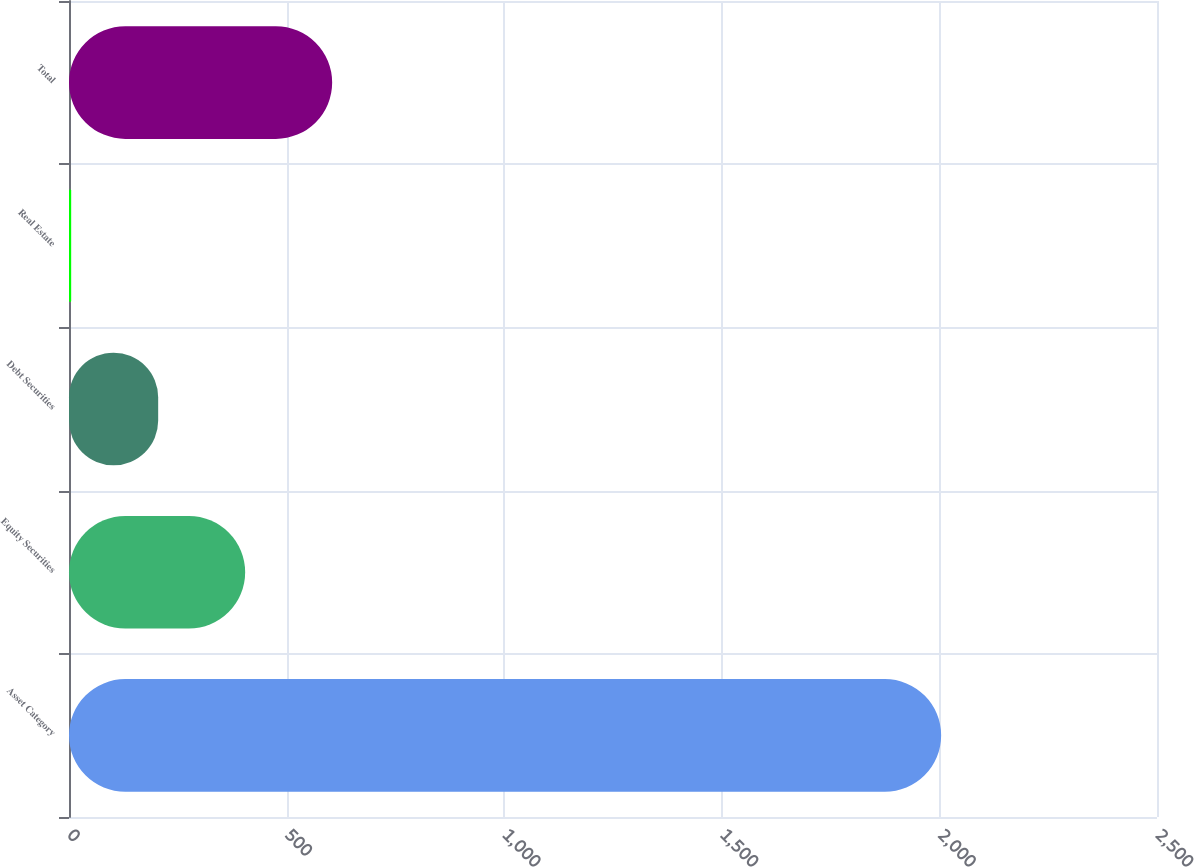Convert chart. <chart><loc_0><loc_0><loc_500><loc_500><bar_chart><fcel>Asset Category<fcel>Equity Securities<fcel>Debt Securities<fcel>Real Estate<fcel>Total<nl><fcel>2004<fcel>404.8<fcel>204.9<fcel>5<fcel>604.7<nl></chart> 